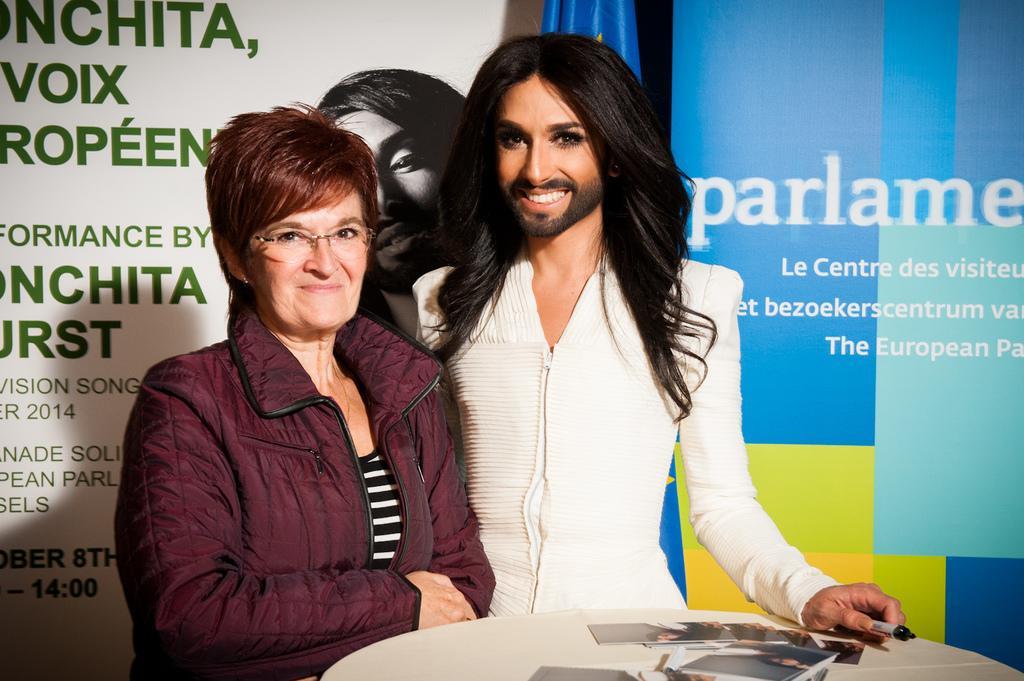Describe this image in one or two sentences. In this image there are two persons standing, in front of them there is a table on that table there are photos, in the background there are banners, on that banners there is some text. 